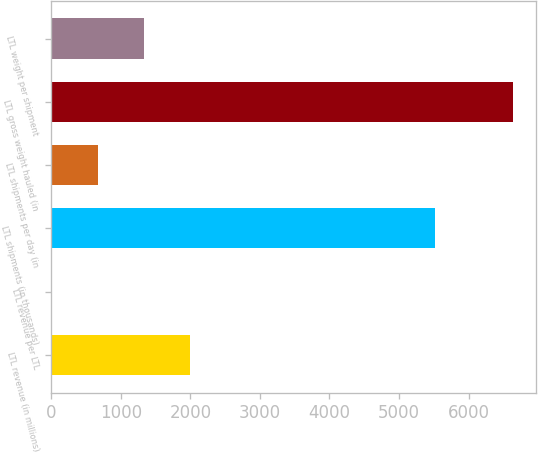Convert chart. <chart><loc_0><loc_0><loc_500><loc_500><bar_chart><fcel>LTL revenue (in millions)<fcel>LTL revenue per LTL<fcel>LTL shipments (in thousands)<fcel>LTL shipments per day (in<fcel>LTL gross weight hauled (in<fcel>LTL weight per shipment<nl><fcel>1993.18<fcel>0.4<fcel>5525<fcel>664.66<fcel>6643<fcel>1328.92<nl></chart> 